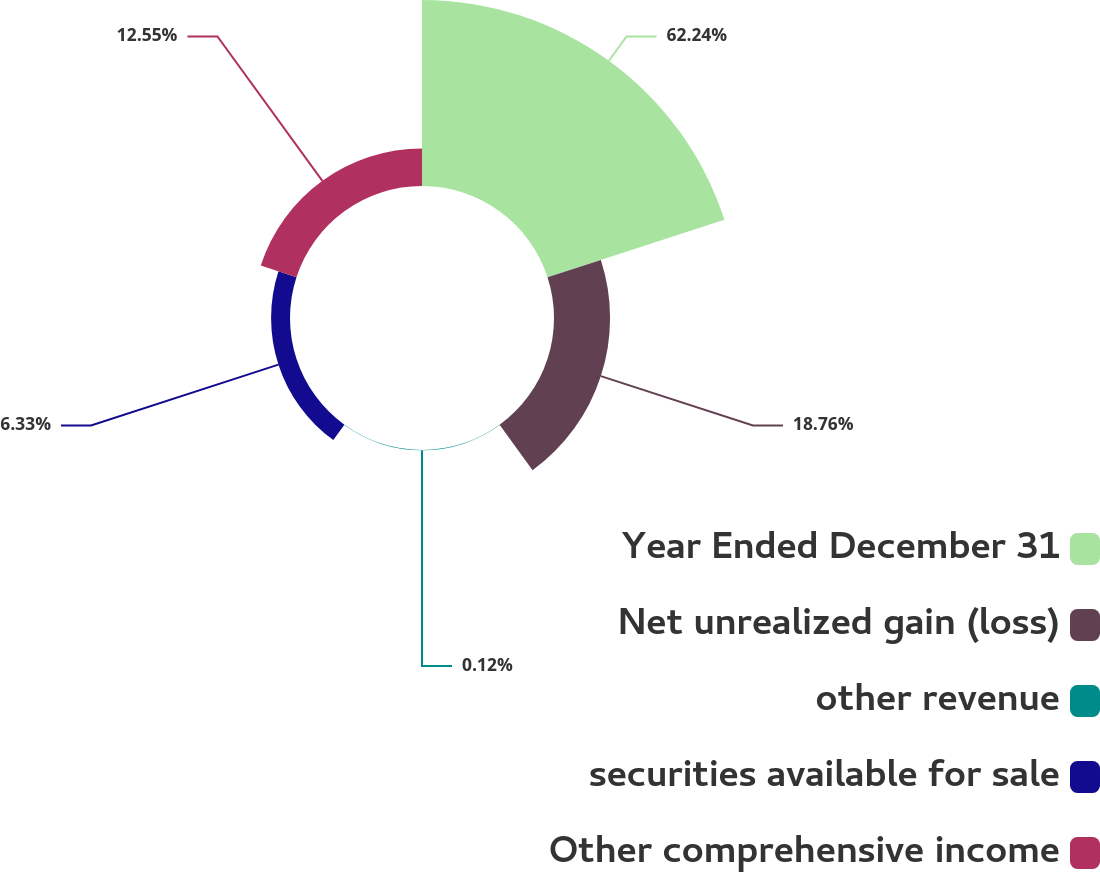<chart> <loc_0><loc_0><loc_500><loc_500><pie_chart><fcel>Year Ended December 31<fcel>Net unrealized gain (loss)<fcel>other revenue<fcel>securities available for sale<fcel>Other comprehensive income<nl><fcel>62.24%<fcel>18.76%<fcel>0.12%<fcel>6.33%<fcel>12.55%<nl></chart> 